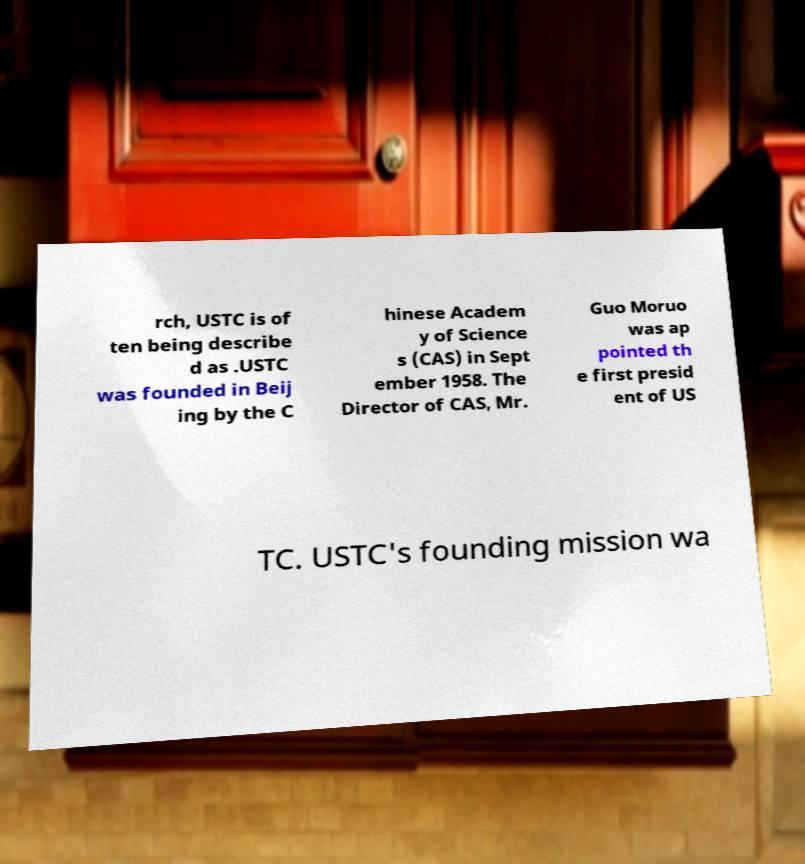There's text embedded in this image that I need extracted. Can you transcribe it verbatim? rch, USTC is of ten being describe d as .USTC was founded in Beij ing by the C hinese Academ y of Science s (CAS) in Sept ember 1958. The Director of CAS, Mr. Guo Moruo was ap pointed th e first presid ent of US TC. USTC's founding mission wa 